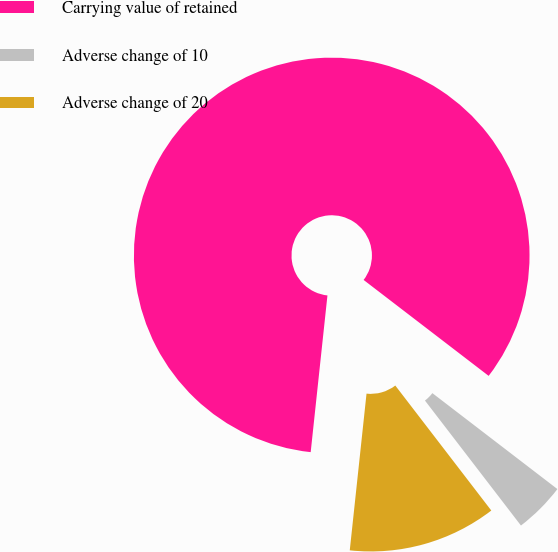Convert chart to OTSL. <chart><loc_0><loc_0><loc_500><loc_500><pie_chart><fcel>Carrying value of retained<fcel>Adverse change of 10<fcel>Adverse change of 20<nl><fcel>83.72%<fcel>4.16%<fcel>12.12%<nl></chart> 